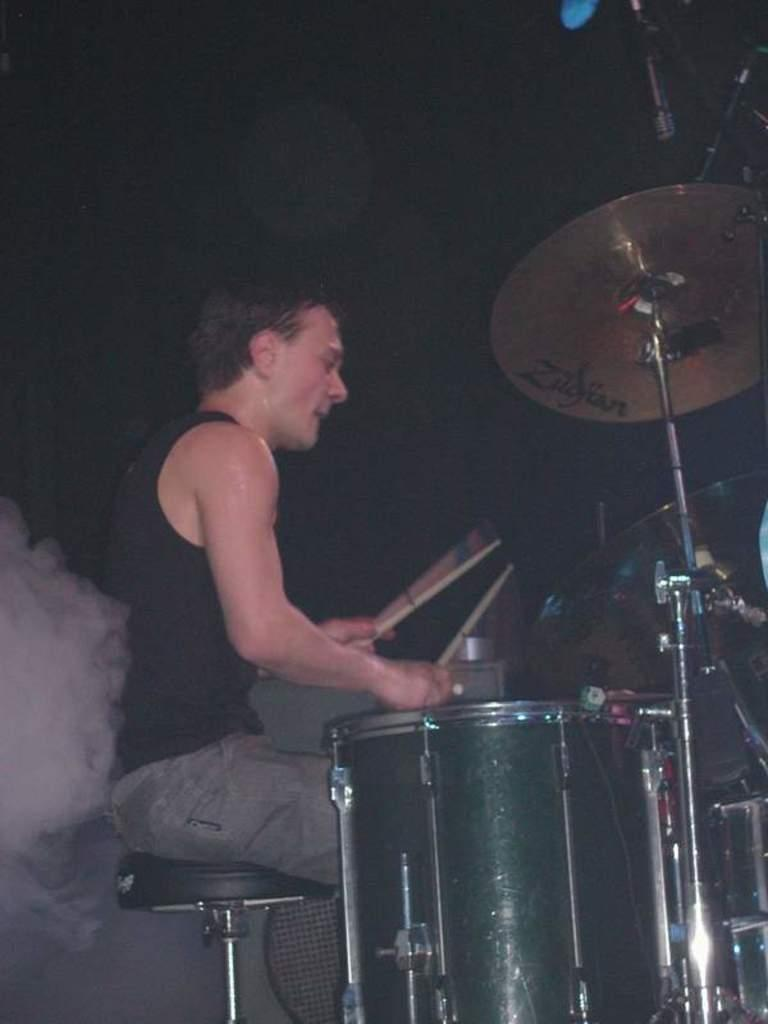Who is the main subject in the image? There is a man in the image. What is the man doing in the image? The man is sitting and playing a band. Can you describe the presence of smoke in the image? There is smoke on the left side of the image. What type of lock is used to secure the man's beliefs in the image? There is no lock or mention of beliefs in the image; it simply shows a man sitting and playing a band with smoke on the left side. 